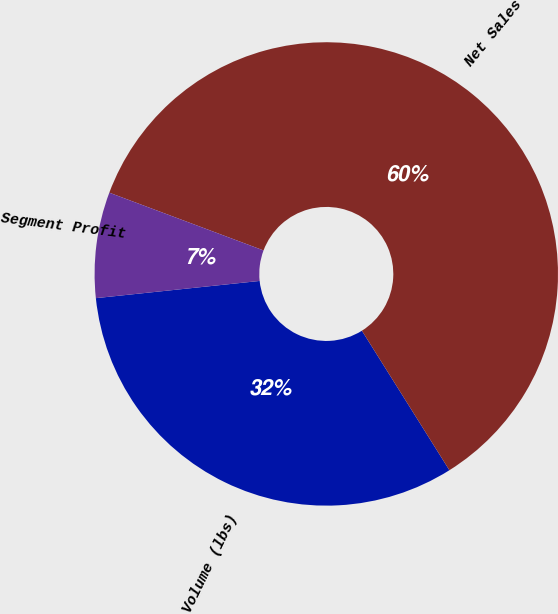<chart> <loc_0><loc_0><loc_500><loc_500><pie_chart><fcel>Volume (lbs)<fcel>Net Sales<fcel>Segment Profit<nl><fcel>32.25%<fcel>60.38%<fcel>7.37%<nl></chart> 